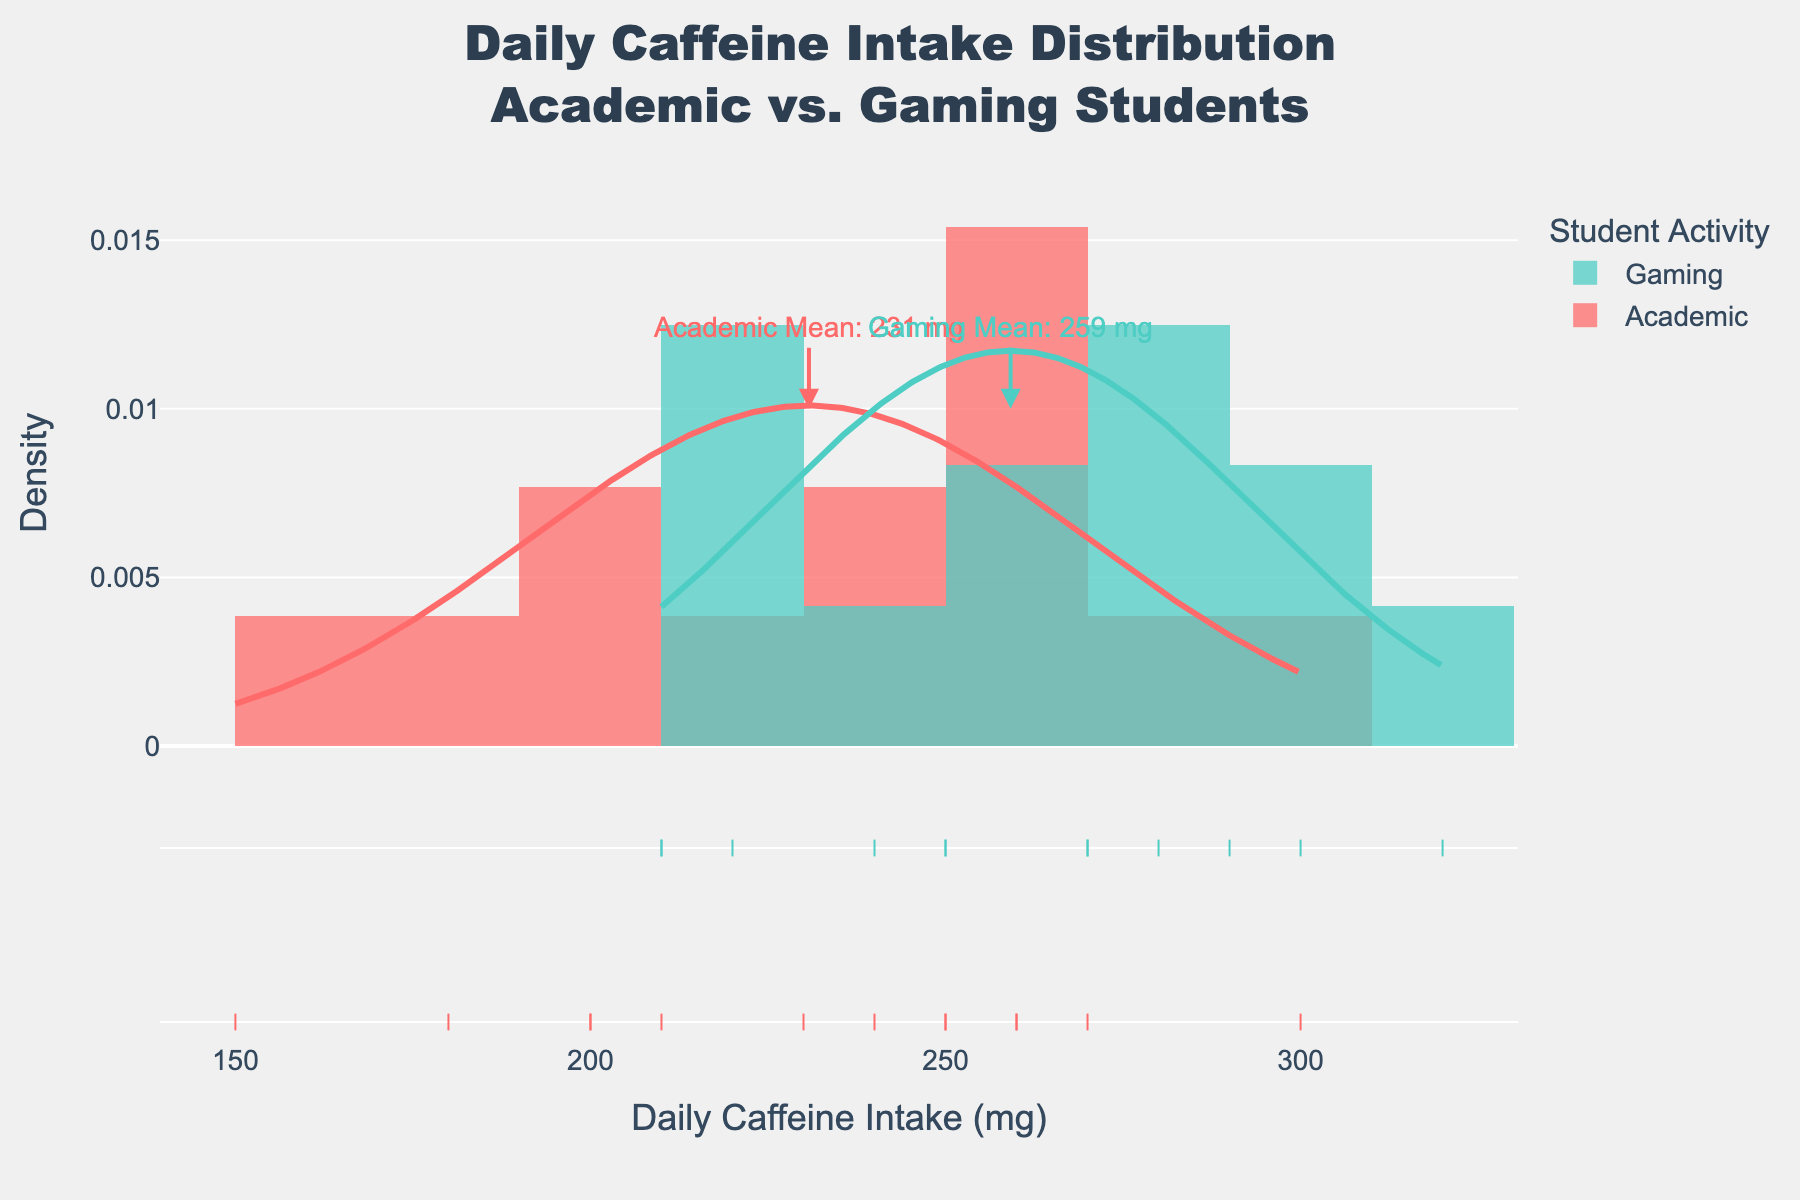What is the title of the figure? The title is located at the top of the figure, and it reads "Daily Caffeine Intake Distribution Academic vs. Gaming Students".
Answer: Daily Caffeine Intake Distribution Academic vs. Gaming Students What are the two groups being compared in the figure? The groups being compared are labeled in the figure's legend and title as "Academic" and "Gaming".
Answer: Academic and Gaming What is the mean daily caffeine intake for academic students? The figure includes an annotation pointing to the mean daily caffeine intake for academic students, which is 232 mg.
Answer: 232 mg What color represents the gaming students in the figure? The color associated with gaming students is shown in the legend and annotations, which is represented by a teal color (#4ECDC4).
Answer: Teal What is the approximate mean daily caffeine intake for gaming students? An annotation in the figure indicates the mean daily caffeine intake for gaming students, which is 263 mg.
Answer: 263 mg Which group has a higher mean daily caffeine intake? By looking at the annotated mean values for both groups, gaming students have a higher mean daily caffeine intake (263 mg) compared to academic students (232 mg).
Answer: Gaming students What can you say about the general shape of the distributions for both groups? The distributions for both groups are shown as smoothed curves overlaid on histograms. Both distributions appear to be normal, with academic students showing a slightly tighter spread around the mean compared to gaming students.
Answer: Both distributions appear normal; academic is tighter How do the densities compare at the peak value for academic and gaming students? The peak value of the density curves can be observed directly. The distribution for academic students has a slightly higher peak compared to the distribution for gaming students, indicating a higher proportion of academic students have their caffeine intake closer to the mean.
Answer: Academic has a higher peak density What range of daily caffeine intake covers the highest density for gaming students? By observing the peak region of the gaming distribution curve, the highest density is within the range of approximately 240 mg to 280 mg daily caffeine intake.
Answer: 240 mg to 280 mg What is the bin size used in the histogram? The histogram's bar width can be inferred; it's explicitly labeled in the creation process of the figure as 20 mg.
Answer: 20 mg 